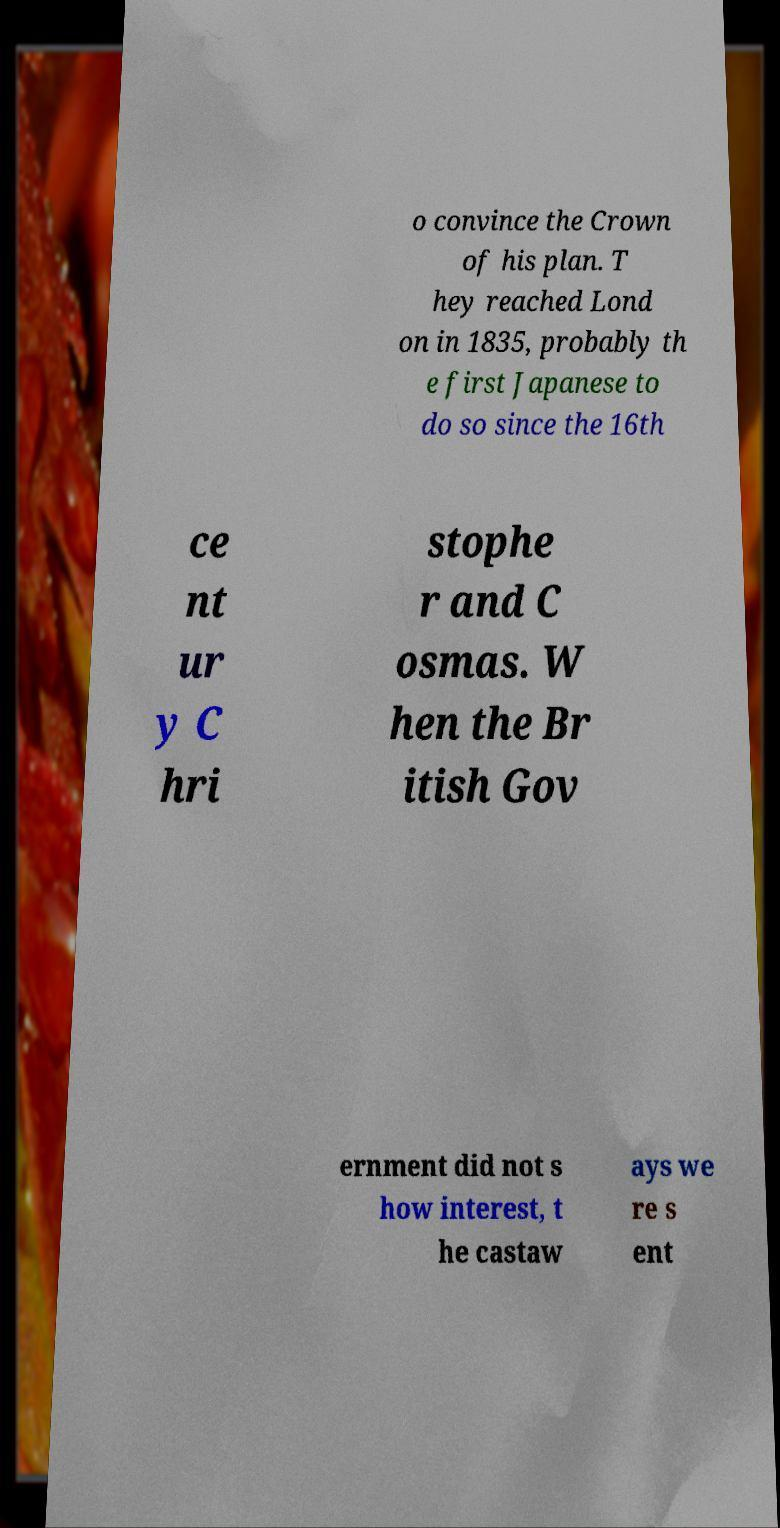Please identify and transcribe the text found in this image. o convince the Crown of his plan. T hey reached Lond on in 1835, probably th e first Japanese to do so since the 16th ce nt ur y C hri stophe r and C osmas. W hen the Br itish Gov ernment did not s how interest, t he castaw ays we re s ent 